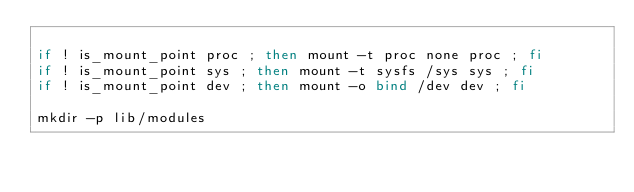Convert code to text. <code><loc_0><loc_0><loc_500><loc_500><_Bash_>
if ! is_mount_point proc ; then mount -t proc none proc ; fi
if ! is_mount_point sys ; then mount -t sysfs /sys sys ; fi
if ! is_mount_point dev ; then mount -o bind /dev dev ; fi

mkdir -p lib/modules</code> 